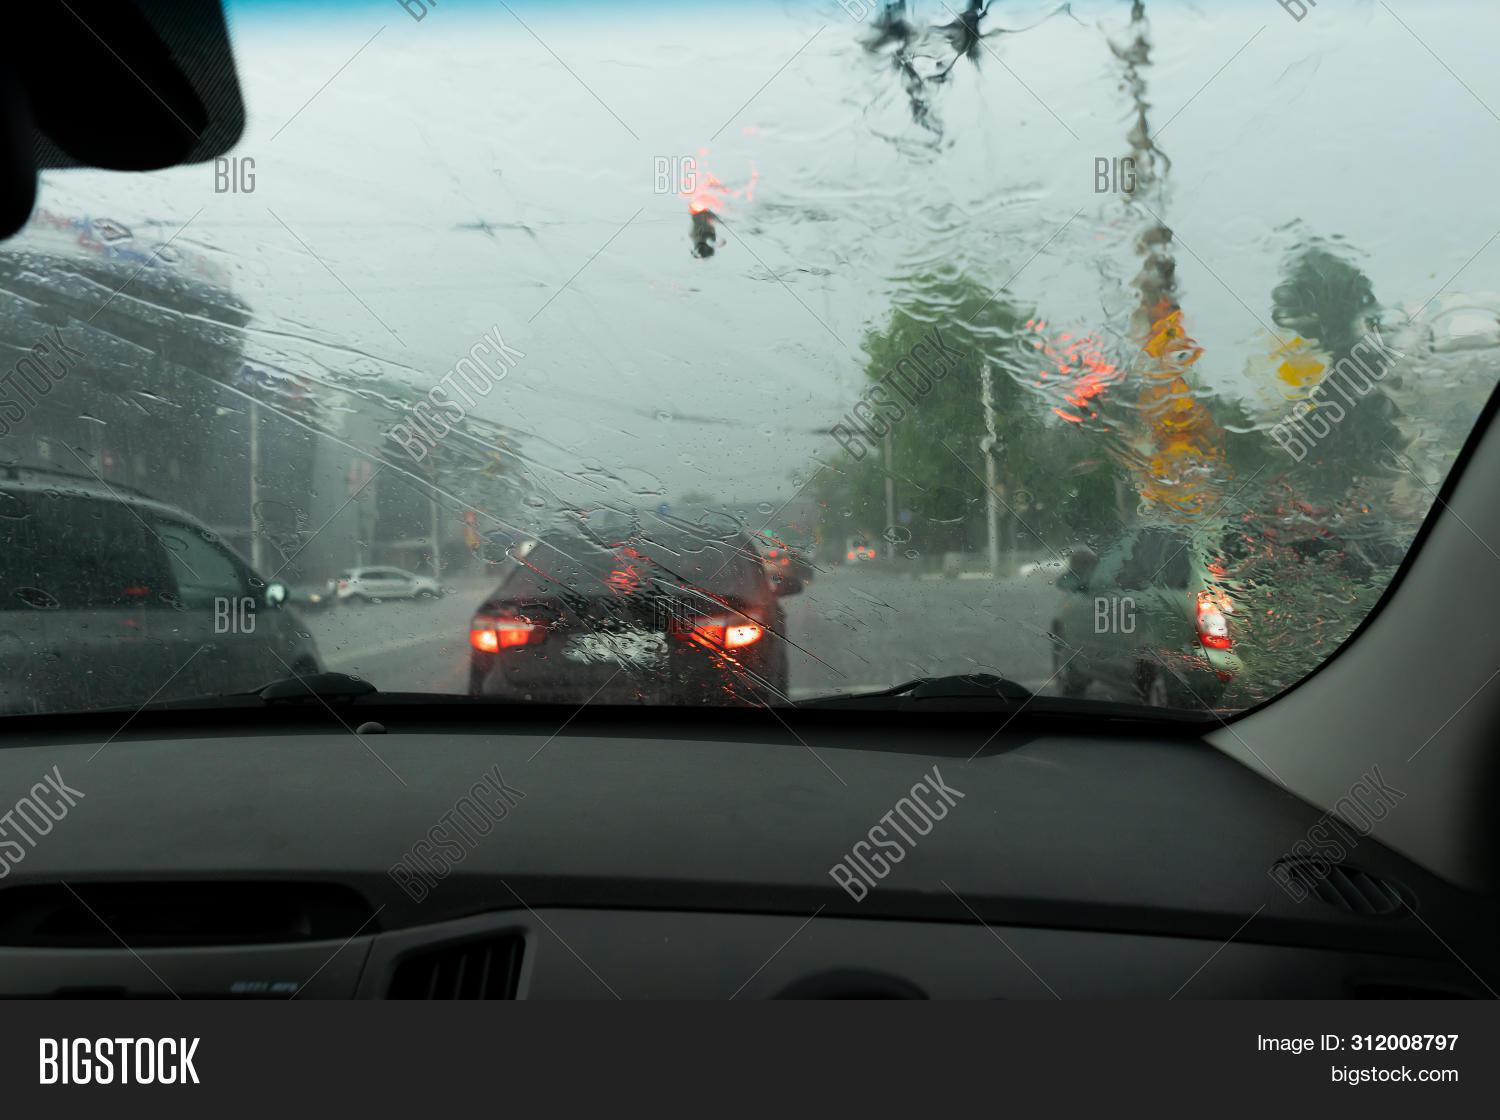How many cars are there in the image? 4 